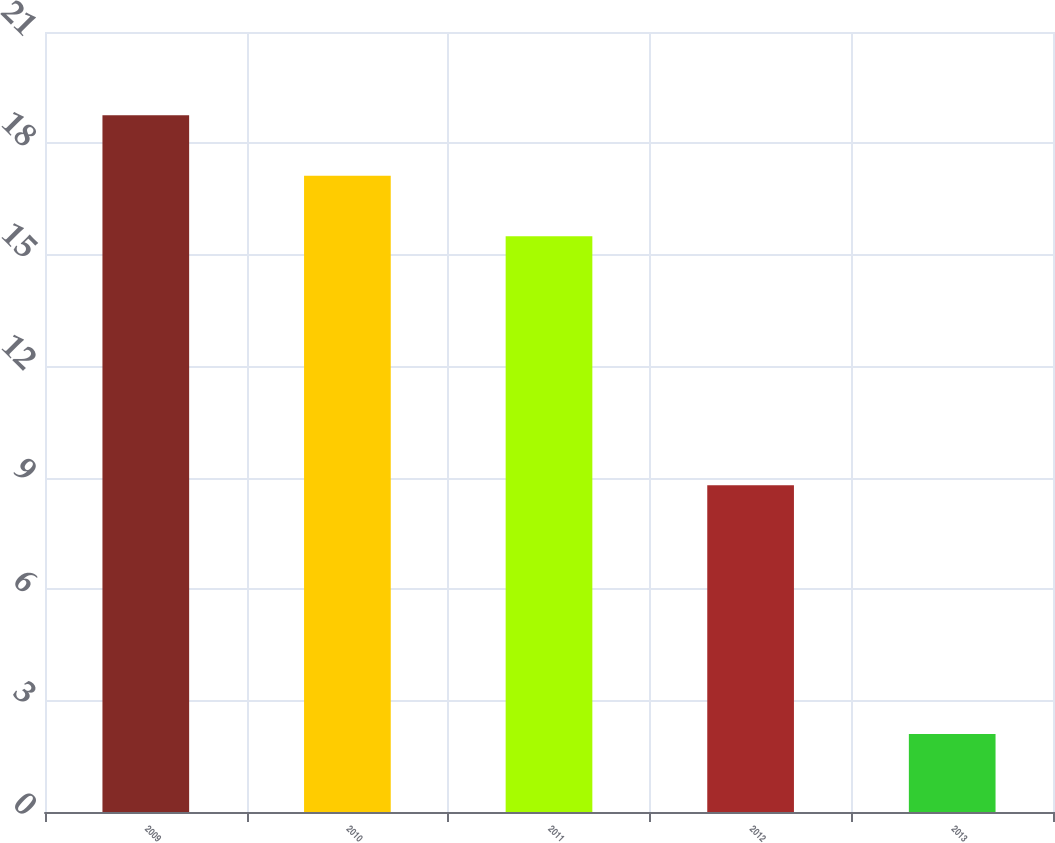<chart> <loc_0><loc_0><loc_500><loc_500><bar_chart><fcel>2009<fcel>2010<fcel>2011<fcel>2012<fcel>2013<nl><fcel>18.76<fcel>17.13<fcel>15.5<fcel>8.8<fcel>2.1<nl></chart> 